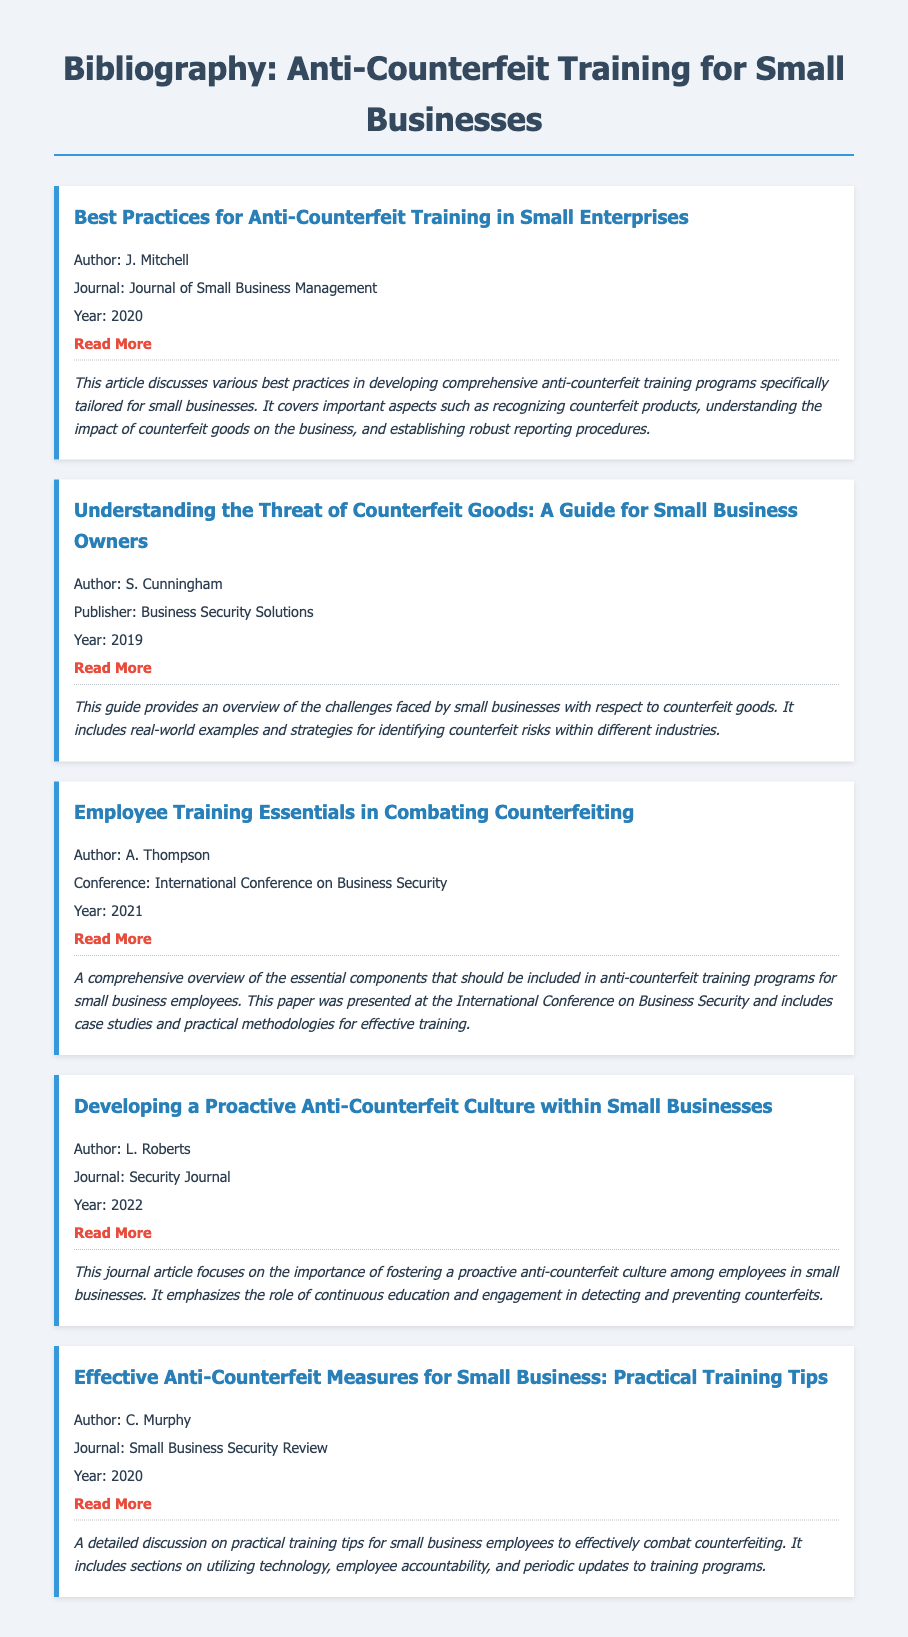What is the title of the first bibliography item? The title can be found within each bibliography item, listed under the `<h2>` tag. The first item is "Best Practices for Anti-Counterfeit Training in Small Enterprises."
Answer: Best Practices for Anti-Counterfeit Training in Small Enterprises Who is the author of the article in the Journal of Small Business Management? The author is mentioned under the `<p>` tag that follows the title in the bibliography item. The author is J. Mitchell.
Answer: J. Mitchell In what year was the paper "Employee Training Essentials in Combating Counterfeiting" presented? The year is stated in the `<p>` tag within the bibliography item detailing the specific conference. It was presented in 2021.
Answer: 2021 What is the main focus of L. Roberts' article? The summary section highlights the content of the article, explaining its focus on anti-counterfeit culture among employees.
Answer: Proactive anti-counterfeit culture How many bibliography items were published in the year 2020? By counting the publication years listed in the respective bibliography items, we find that two items were published in 2020.
Answer: 2 What type of document is this? The structure and content of the document conform to the characteristics of a bibliography, which lists sources and their details for reference.
Answer: Bibliography Which author wrote about "Effective Anti-Counterfeit Measures for Small Business"? The information can be found under the author section of the corresponding bibliography item. The author is C. Murphy.
Answer: C. Murphy Which journal published an article by S. Cunningham in 2019? This can be determined from the publisher information section found in the corresponding bibliography item for S. Cunningham. The publisher is Business Security Solutions.
Answer: Business Security Solutions 